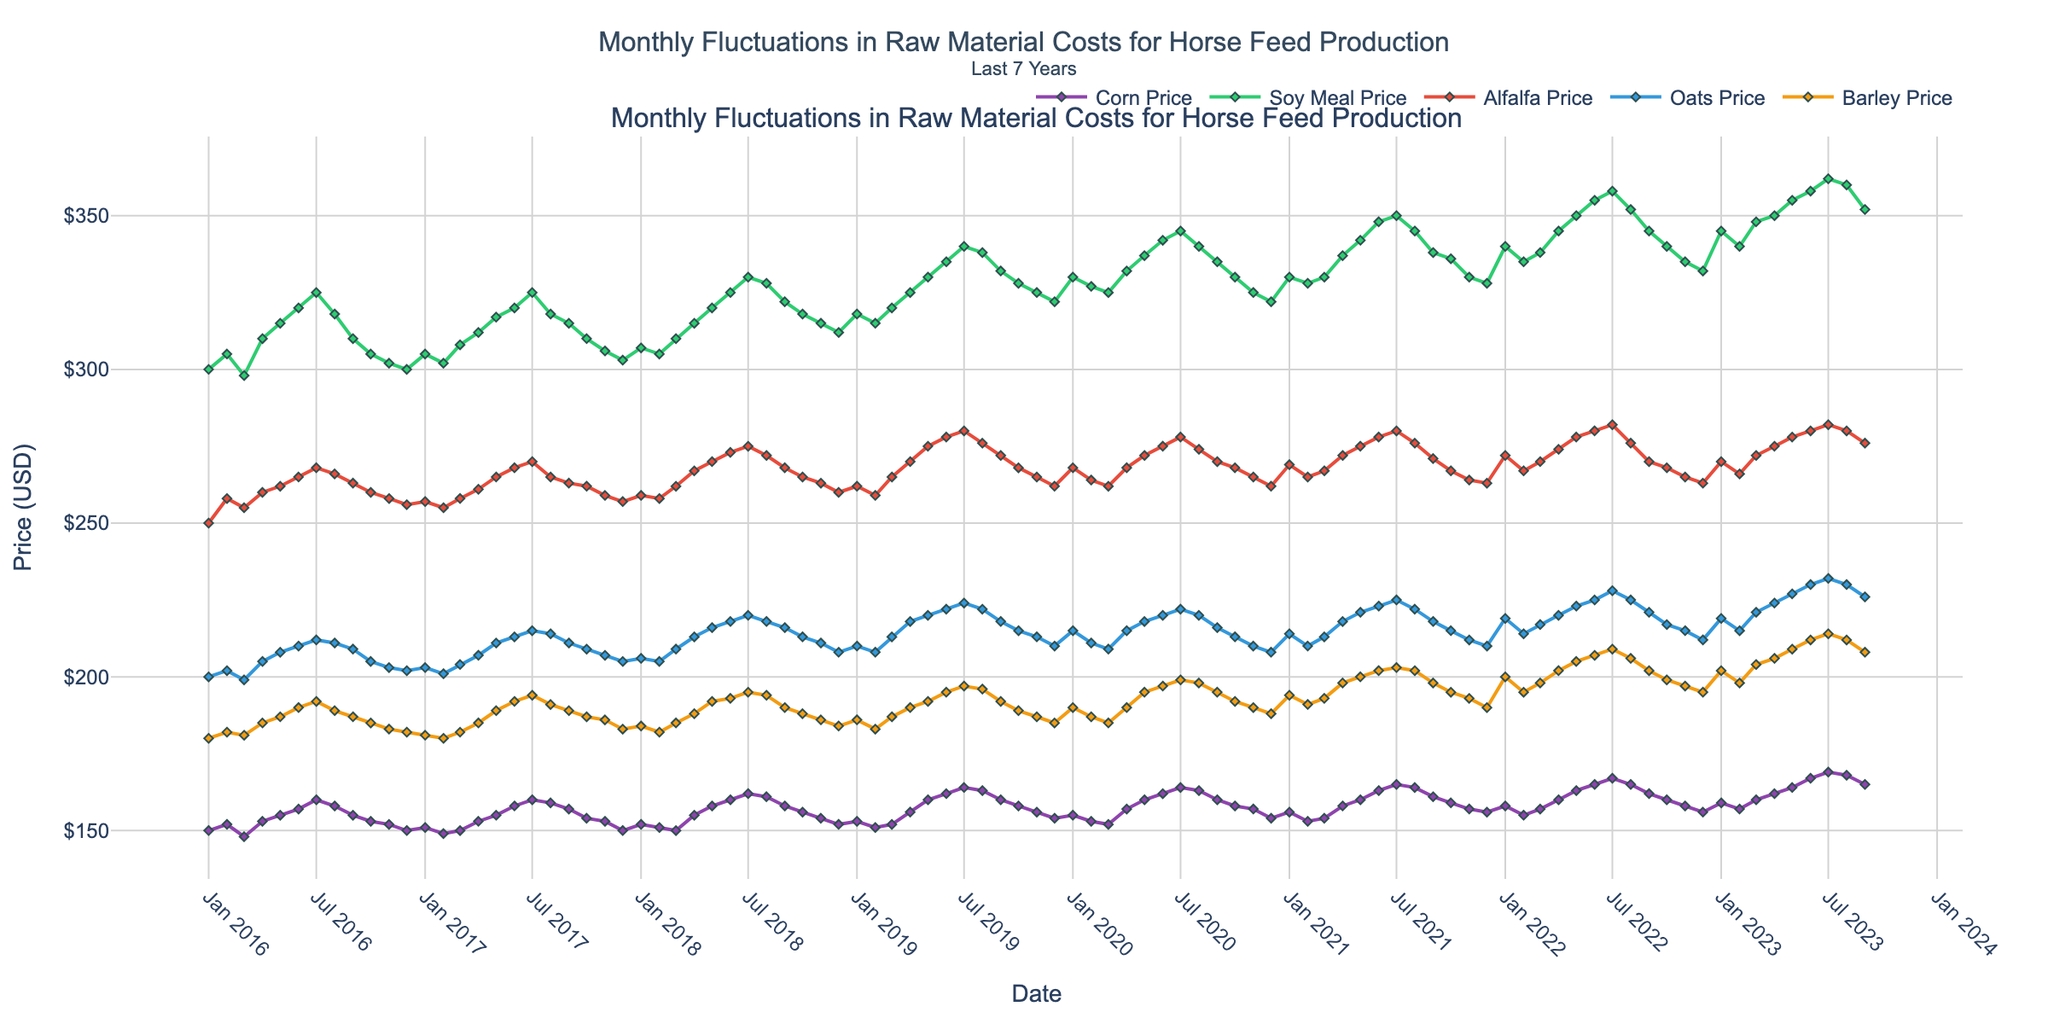What is the title of the figure? The title of the figure is at the top, centered, and includes both the main title and a subtitle. The main title is "Monthly Fluctuations in Raw Material Costs for Horse Feed Production," and the subtitle is "Last 7 Years".
Answer: Monthly Fluctuations in Raw Material Costs for Horse Feed Production; Last 7 Years What does the x-axis represent? The x-axis represents time, specifically the date, formatted to display months and years.
Answer: Date What color represents the cost of corn over time? The color representing the cost of corn is indicated by the legend associated with its corresponding line. This line is colored in a shade of purple.
Answer: Purple Which month and year had the highest price for soy meal? To find this, locate the peak point on the soy meal price line (green) and note the corresponding date on the x-axis. The highest value appears around July 2022.
Answer: July 2022 How does the price of alfalfa in January 2019 compare with that in January 2020? Find the price points for alfalfa (red) in January 2019 and January 2020; compare the positions of these two points vertically. January 2020 had a higher price than January 2019.
Answer: January 2020 is higher What is the average price of oats for the entire period? Average is calculated by summing the monthly prices of oats over the period and dividing by the number of months. This requires summing all prices from the blue line and dividing by the count of data points.
Answer: Calculations show the average is approximately $214 Which raw material fluctuated the least over the entire time period? By comparing the range of fluctuations visually for corn (purple), soy meal (green), alfalfa (red), oats (blue), and barley (orange), corn shows the least fluctuation with the smallest range of price movements.
Answer: Corn What is the trend in barley prices from January 2021 to January 2023? Inspect the orange line from January 2021 to January 2023 to determine if it's rising, falling, or staying constant. The trend shows an increasing price.
Answer: Increasing In which months did corn prices decrease from the previous month? Identify months where the purple line shows a downward movement from one point to the next. Noticeable decreases are in March 2016, February 2017, February 2018, August 2018, February 2019, August 2019, February 2020, August 2020, October 2020, August 2021, and September 2023.
Answer: Multiple months, including March 2016, February 2017, February 2018, August 2018, February 2019, August 2019, February 2020, August 2020, October 2020, August 2021, September 2023 Which raw material had the highest price increase between January 2020 and January 2021? Compare price changes from January 2020 to January 2021 for all materials. Calculate differences: Corn: $156-$154=$2, Soy Meal: $330-$322=$8, Alfalfa: $269-$262=$7, Oats: $214-$210=$4, Barley: $194-$190=$4. Soy meal had the highest increase of $8.
Answer: Soy Meal (increase of $8) 